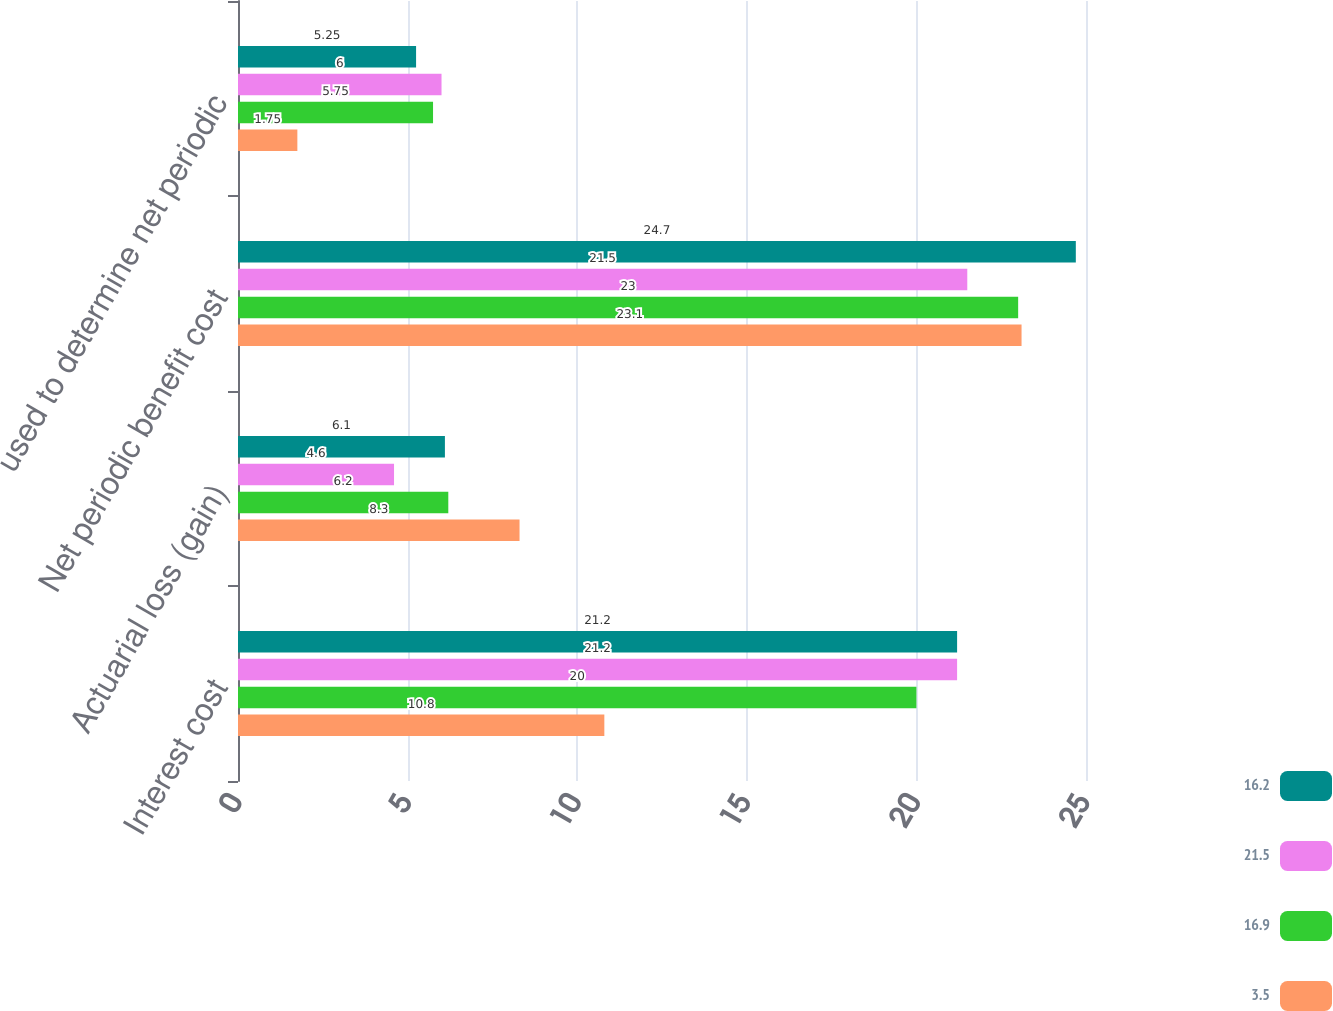Convert chart. <chart><loc_0><loc_0><loc_500><loc_500><stacked_bar_chart><ecel><fcel>Interest cost<fcel>Actuarial loss (gain)<fcel>Net periodic benefit cost<fcel>used to determine net periodic<nl><fcel>16.2<fcel>21.2<fcel>6.1<fcel>24.7<fcel>5.25<nl><fcel>21.5<fcel>21.2<fcel>4.6<fcel>21.5<fcel>6<nl><fcel>16.9<fcel>20<fcel>6.2<fcel>23<fcel>5.75<nl><fcel>3.5<fcel>10.8<fcel>8.3<fcel>23.1<fcel>1.75<nl></chart> 